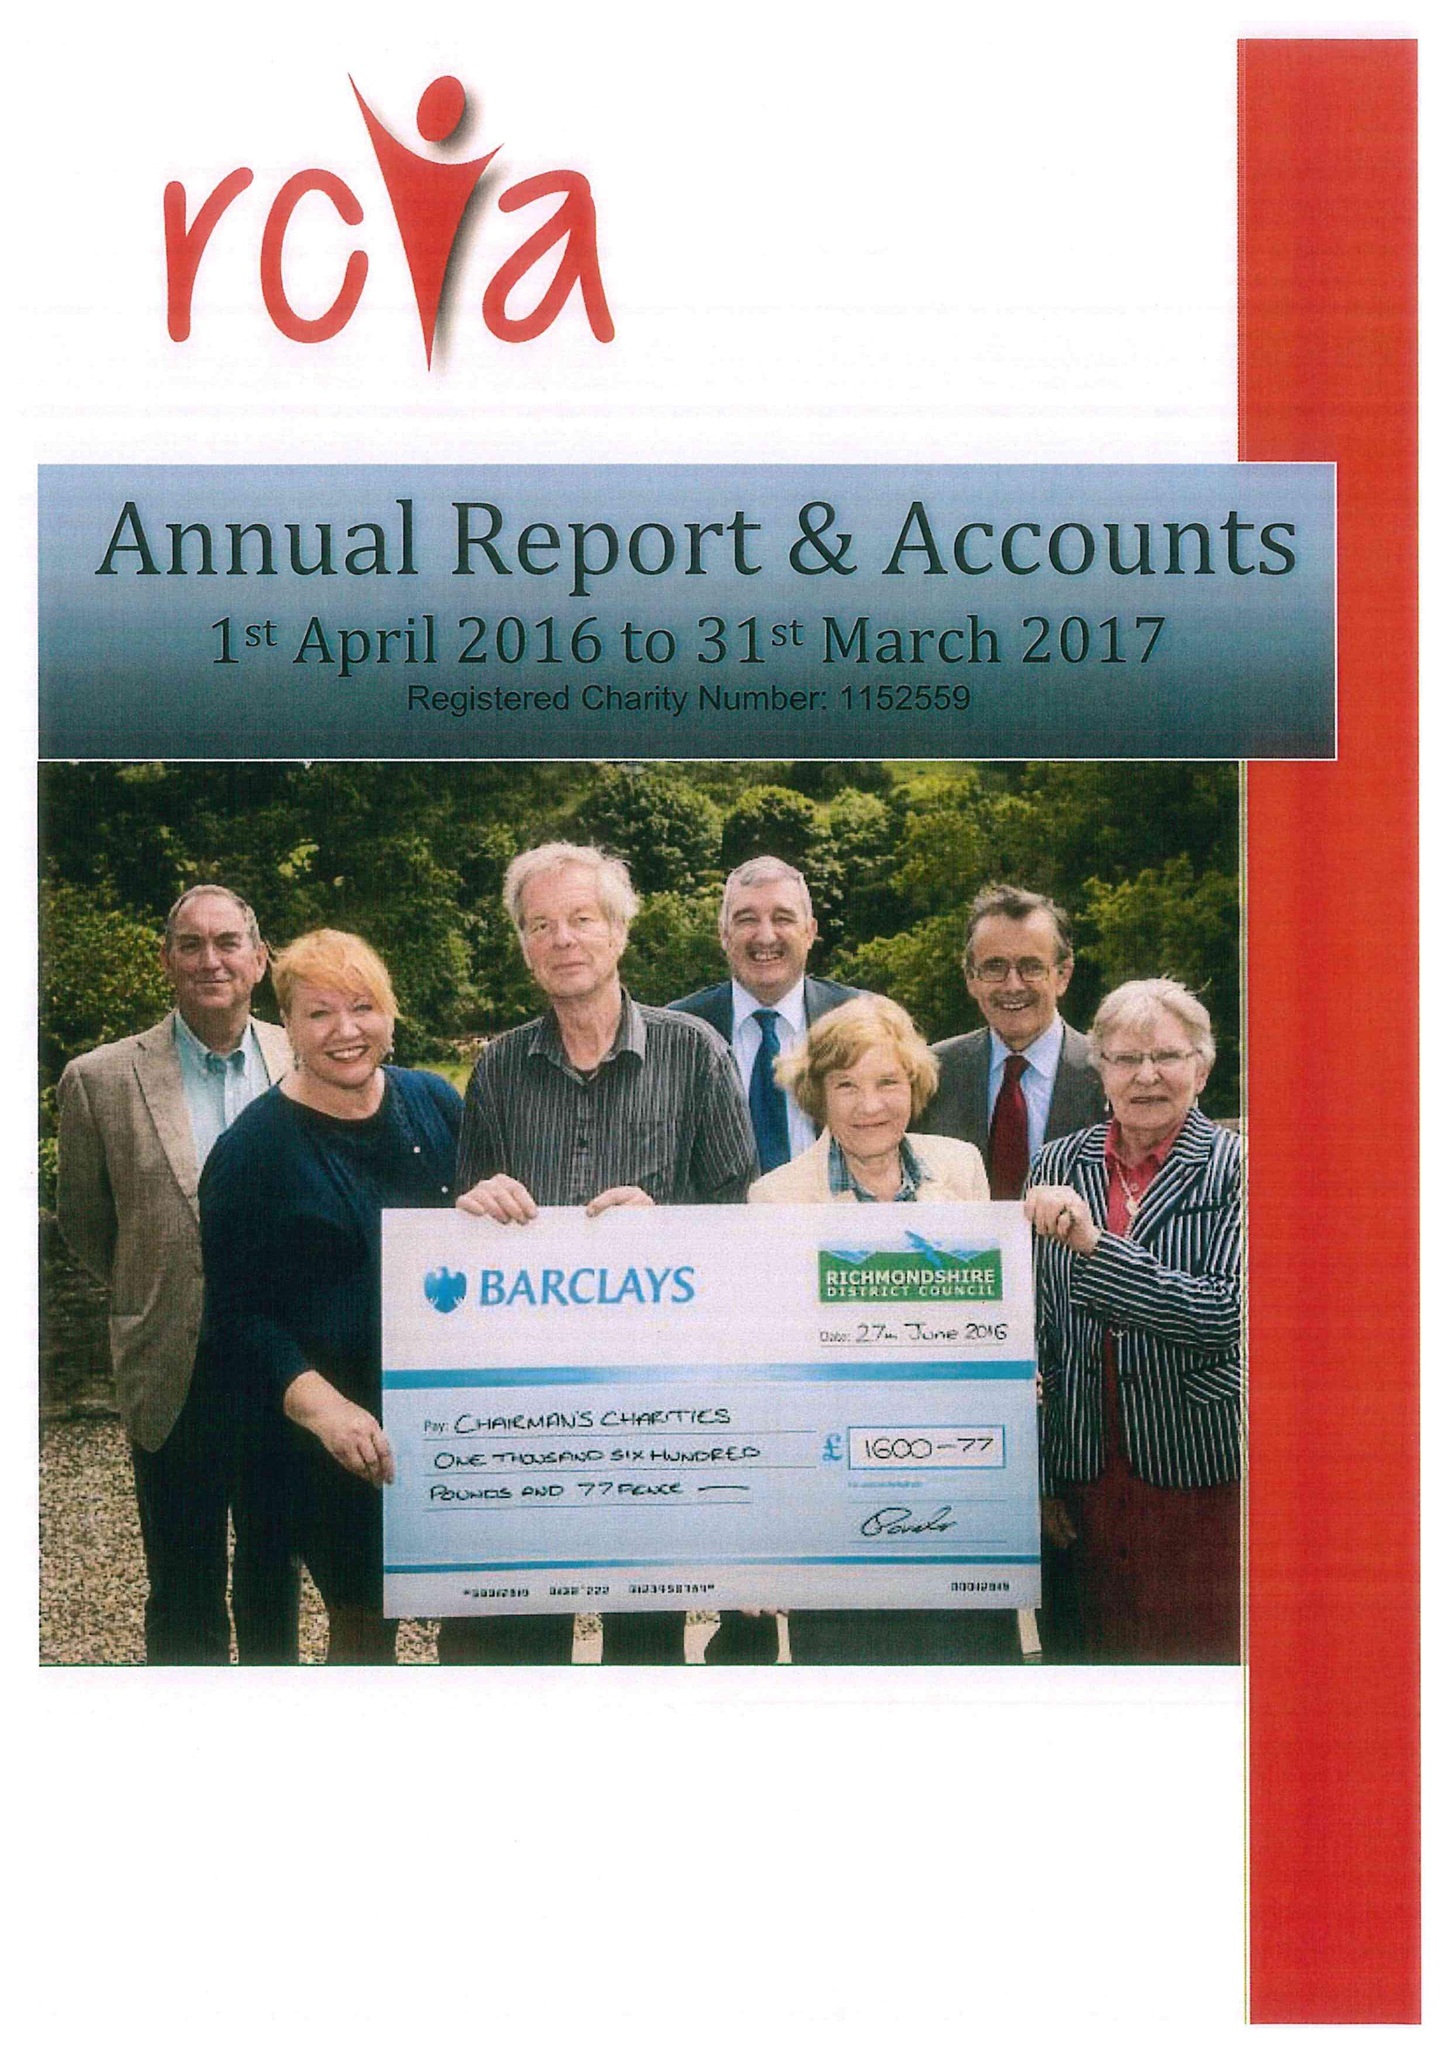What is the value for the report_date?
Answer the question using a single word or phrase. 2017-03-31 